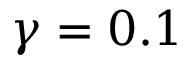Convert formula to latex. <formula><loc_0><loc_0><loc_500><loc_500>\gamma = 0 . 1</formula> 